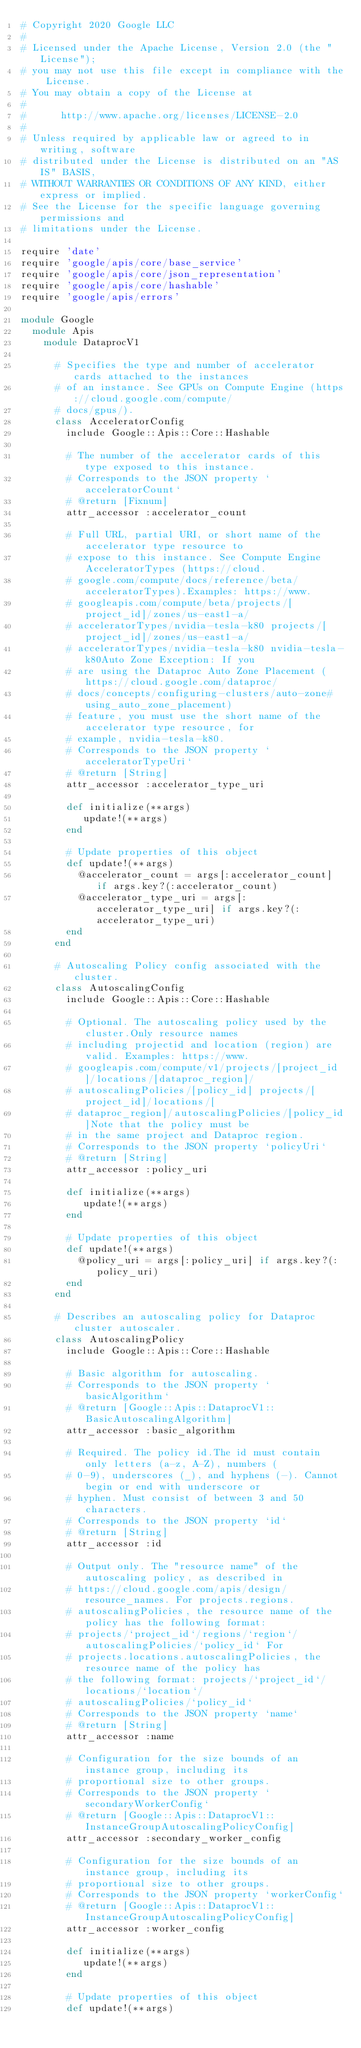<code> <loc_0><loc_0><loc_500><loc_500><_Ruby_># Copyright 2020 Google LLC
#
# Licensed under the Apache License, Version 2.0 (the "License");
# you may not use this file except in compliance with the License.
# You may obtain a copy of the License at
#
#      http://www.apache.org/licenses/LICENSE-2.0
#
# Unless required by applicable law or agreed to in writing, software
# distributed under the License is distributed on an "AS IS" BASIS,
# WITHOUT WARRANTIES OR CONDITIONS OF ANY KIND, either express or implied.
# See the License for the specific language governing permissions and
# limitations under the License.

require 'date'
require 'google/apis/core/base_service'
require 'google/apis/core/json_representation'
require 'google/apis/core/hashable'
require 'google/apis/errors'

module Google
  module Apis
    module DataprocV1
      
      # Specifies the type and number of accelerator cards attached to the instances
      # of an instance. See GPUs on Compute Engine (https://cloud.google.com/compute/
      # docs/gpus/).
      class AcceleratorConfig
        include Google::Apis::Core::Hashable
      
        # The number of the accelerator cards of this type exposed to this instance.
        # Corresponds to the JSON property `acceleratorCount`
        # @return [Fixnum]
        attr_accessor :accelerator_count
      
        # Full URL, partial URI, or short name of the accelerator type resource to
        # expose to this instance. See Compute Engine AcceleratorTypes (https://cloud.
        # google.com/compute/docs/reference/beta/acceleratorTypes).Examples: https://www.
        # googleapis.com/compute/beta/projects/[project_id]/zones/us-east1-a/
        # acceleratorTypes/nvidia-tesla-k80 projects/[project_id]/zones/us-east1-a/
        # acceleratorTypes/nvidia-tesla-k80 nvidia-tesla-k80Auto Zone Exception: If you
        # are using the Dataproc Auto Zone Placement (https://cloud.google.com/dataproc/
        # docs/concepts/configuring-clusters/auto-zone#using_auto_zone_placement)
        # feature, you must use the short name of the accelerator type resource, for
        # example, nvidia-tesla-k80.
        # Corresponds to the JSON property `acceleratorTypeUri`
        # @return [String]
        attr_accessor :accelerator_type_uri
      
        def initialize(**args)
           update!(**args)
        end
      
        # Update properties of this object
        def update!(**args)
          @accelerator_count = args[:accelerator_count] if args.key?(:accelerator_count)
          @accelerator_type_uri = args[:accelerator_type_uri] if args.key?(:accelerator_type_uri)
        end
      end
      
      # Autoscaling Policy config associated with the cluster.
      class AutoscalingConfig
        include Google::Apis::Core::Hashable
      
        # Optional. The autoscaling policy used by the cluster.Only resource names
        # including projectid and location (region) are valid. Examples: https://www.
        # googleapis.com/compute/v1/projects/[project_id]/locations/[dataproc_region]/
        # autoscalingPolicies/[policy_id] projects/[project_id]/locations/[
        # dataproc_region]/autoscalingPolicies/[policy_id]Note that the policy must be
        # in the same project and Dataproc region.
        # Corresponds to the JSON property `policyUri`
        # @return [String]
        attr_accessor :policy_uri
      
        def initialize(**args)
           update!(**args)
        end
      
        # Update properties of this object
        def update!(**args)
          @policy_uri = args[:policy_uri] if args.key?(:policy_uri)
        end
      end
      
      # Describes an autoscaling policy for Dataproc cluster autoscaler.
      class AutoscalingPolicy
        include Google::Apis::Core::Hashable
      
        # Basic algorithm for autoscaling.
        # Corresponds to the JSON property `basicAlgorithm`
        # @return [Google::Apis::DataprocV1::BasicAutoscalingAlgorithm]
        attr_accessor :basic_algorithm
      
        # Required. The policy id.The id must contain only letters (a-z, A-Z), numbers (
        # 0-9), underscores (_), and hyphens (-). Cannot begin or end with underscore or
        # hyphen. Must consist of between 3 and 50 characters.
        # Corresponds to the JSON property `id`
        # @return [String]
        attr_accessor :id
      
        # Output only. The "resource name" of the autoscaling policy, as described in
        # https://cloud.google.com/apis/design/resource_names. For projects.regions.
        # autoscalingPolicies, the resource name of the policy has the following format:
        # projects/`project_id`/regions/`region`/autoscalingPolicies/`policy_id` For
        # projects.locations.autoscalingPolicies, the resource name of the policy has
        # the following format: projects/`project_id`/locations/`location`/
        # autoscalingPolicies/`policy_id`
        # Corresponds to the JSON property `name`
        # @return [String]
        attr_accessor :name
      
        # Configuration for the size bounds of an instance group, including its
        # proportional size to other groups.
        # Corresponds to the JSON property `secondaryWorkerConfig`
        # @return [Google::Apis::DataprocV1::InstanceGroupAutoscalingPolicyConfig]
        attr_accessor :secondary_worker_config
      
        # Configuration for the size bounds of an instance group, including its
        # proportional size to other groups.
        # Corresponds to the JSON property `workerConfig`
        # @return [Google::Apis::DataprocV1::InstanceGroupAutoscalingPolicyConfig]
        attr_accessor :worker_config
      
        def initialize(**args)
           update!(**args)
        end
      
        # Update properties of this object
        def update!(**args)</code> 